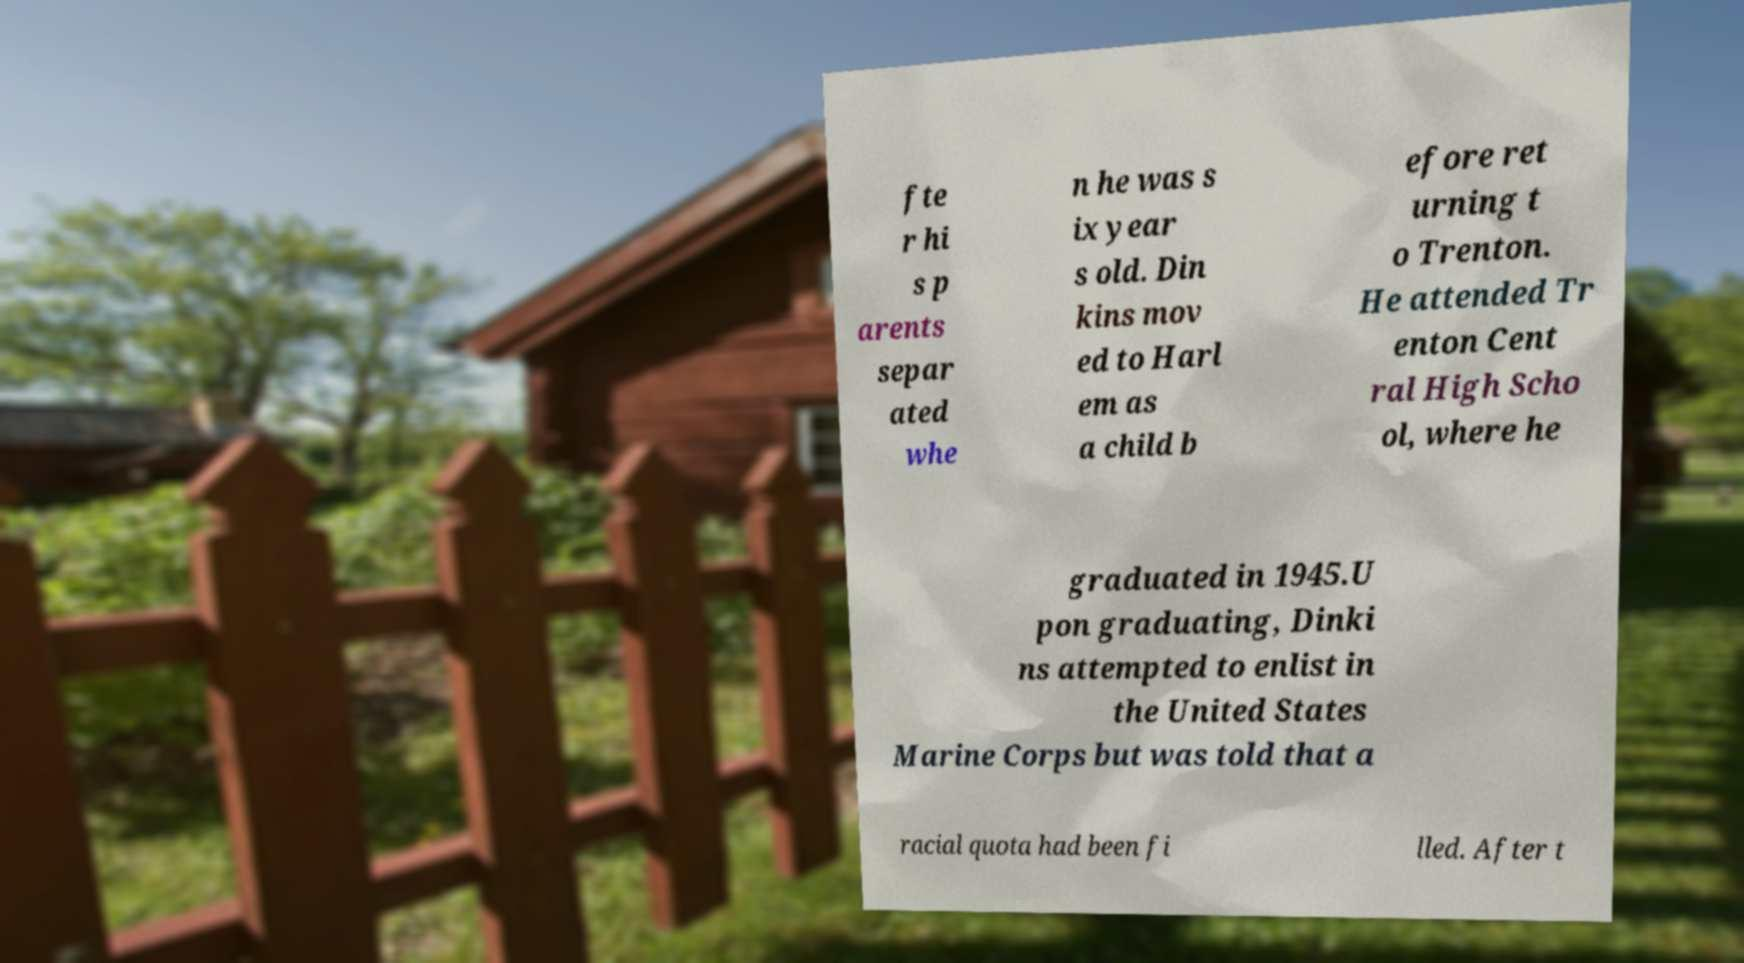Can you read and provide the text displayed in the image?This photo seems to have some interesting text. Can you extract and type it out for me? fte r hi s p arents separ ated whe n he was s ix year s old. Din kins mov ed to Harl em as a child b efore ret urning t o Trenton. He attended Tr enton Cent ral High Scho ol, where he graduated in 1945.U pon graduating, Dinki ns attempted to enlist in the United States Marine Corps but was told that a racial quota had been fi lled. After t 